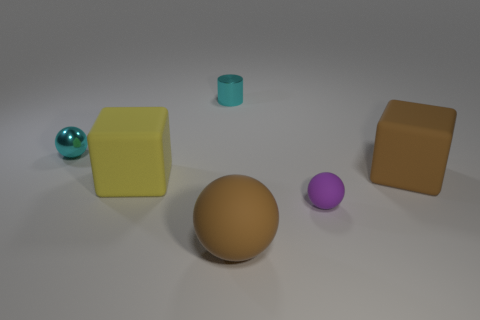Add 1 tiny metallic blocks. How many objects exist? 7 Subtract all cubes. How many objects are left? 4 Subtract all small gray rubber balls. Subtract all cyan objects. How many objects are left? 4 Add 3 purple matte spheres. How many purple matte spheres are left? 4 Add 2 blue matte objects. How many blue matte objects exist? 2 Subtract 0 cyan cubes. How many objects are left? 6 